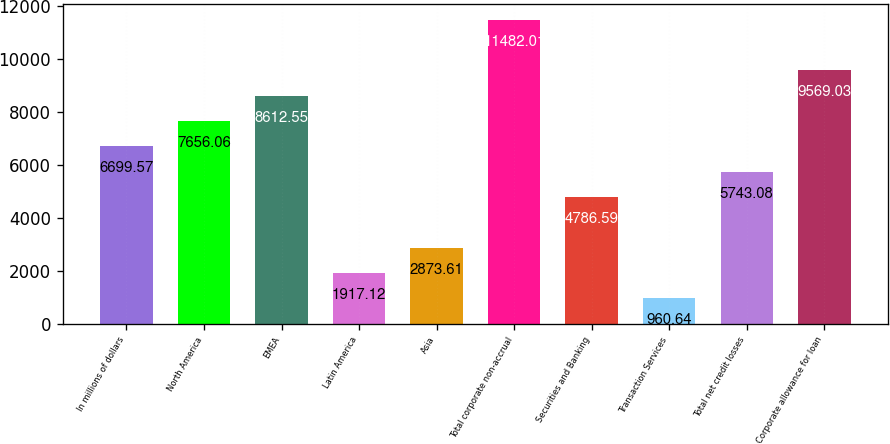Convert chart to OTSL. <chart><loc_0><loc_0><loc_500><loc_500><bar_chart><fcel>In millions of dollars<fcel>North America<fcel>EMEA<fcel>Latin America<fcel>Asia<fcel>Total corporate non-accrual<fcel>Securities and Banking<fcel>Transaction Services<fcel>Total net credit losses<fcel>Corporate allowance for loan<nl><fcel>6699.57<fcel>7656.06<fcel>8612.55<fcel>1917.12<fcel>2873.61<fcel>11482<fcel>4786.59<fcel>960.64<fcel>5743.08<fcel>9569.03<nl></chart> 